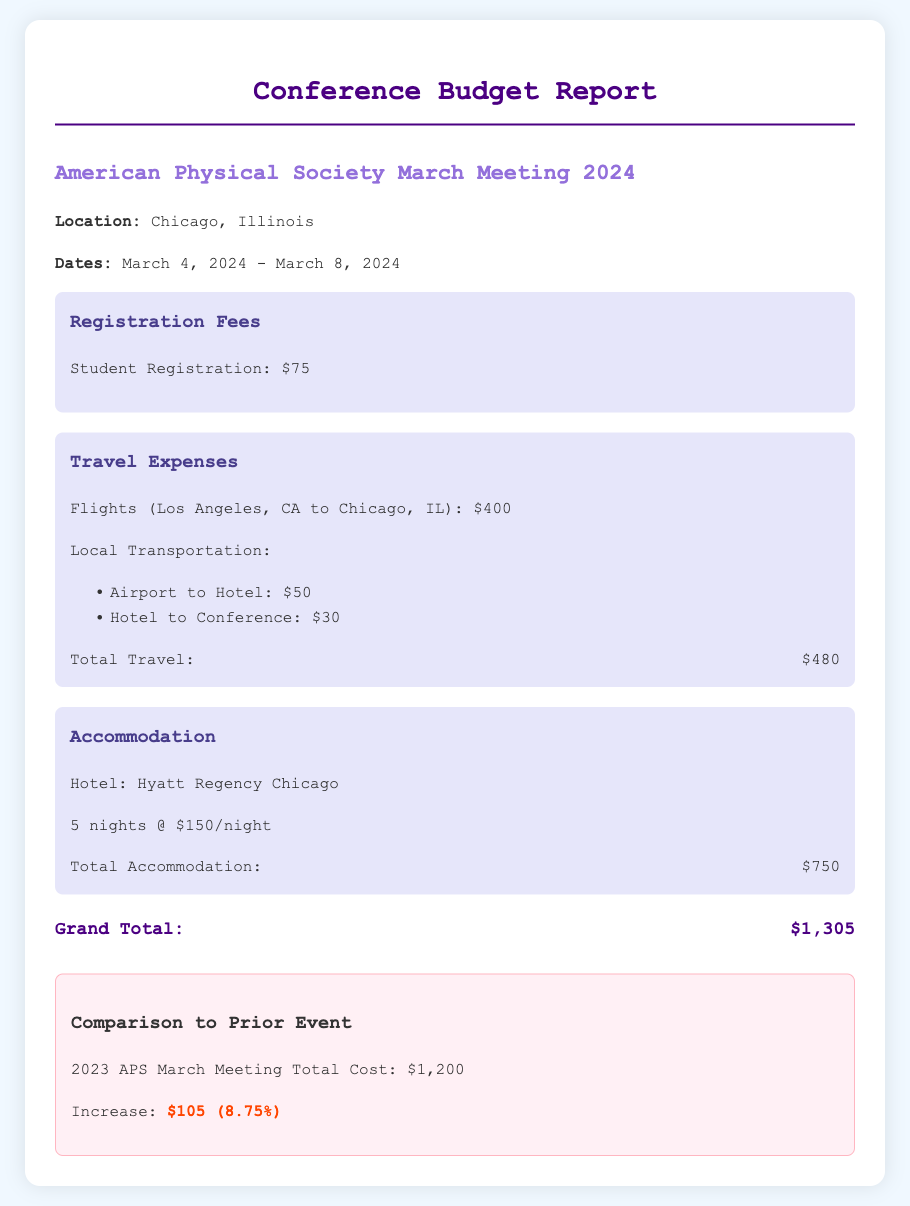What is the location of the conference? The location of the conference is listed in the document as Chicago, Illinois.
Answer: Chicago, Illinois What is the registration fee for students? The registration fee for students is specifically mentioned in the budget section as $75.
Answer: $75 What are the total travel expenses? The total travel expenses are calculated from different components, adding flights and local transportation, resulting in $480.
Answer: $480 How much is the accommodation cost per night? The accommodation cost per night is provided as $150 in the hotel information section.
Answer: $150 What is the grand total budget for the conference? The grand total budget is found at the bottom of the document, which sums up all the expenses to $1,305.
Answer: $1,305 What was the total cost of the 2023 APS March Meeting? The total cost of the prior event is specified as $1,200 in the comparison section of the document.
Answer: $1,200 How much did the costs increase compared to last year's conference? The increase in costs is detailed in the comparison section, where it states an increase of $105.
Answer: $105 What percentage increase is indicated from the previous year's costs? The percentage increase is provided as 8.75% in the comparison section, calculated from the increase amount.
Answer: 8.75% What hotel will be used for accommodation? The document specifies that the accommodation will be at the Hyatt Regency Chicago.
Answer: Hyatt Regency Chicago 